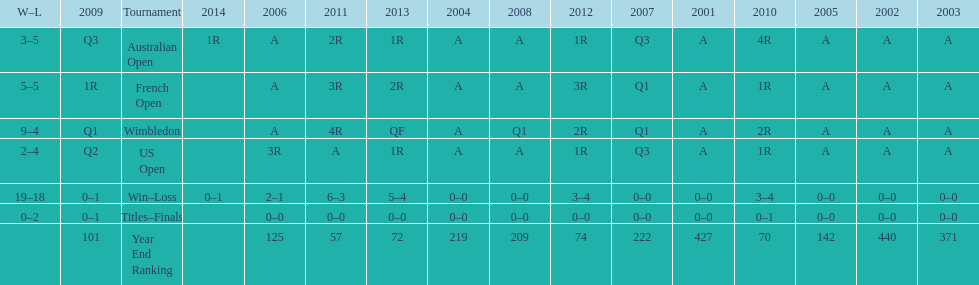What was the total number of matches played from 2001 to 2014? 37. 